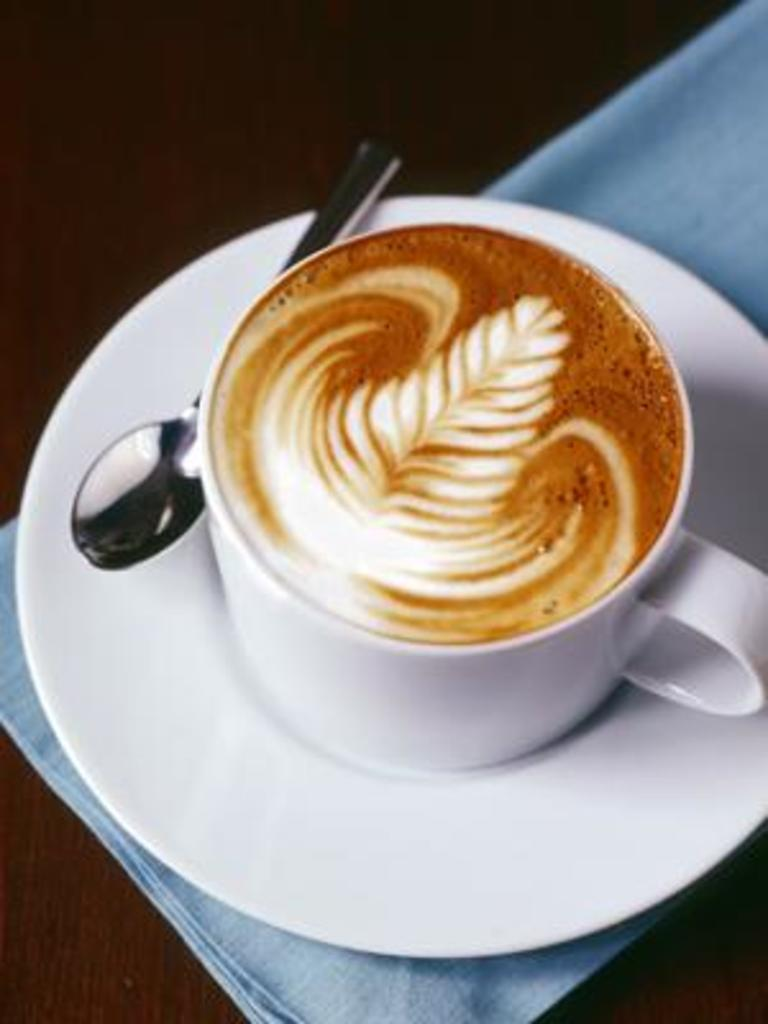What is present on the table in the image? There is a coffee cup, a saucer, and a spoon in the image. What might be used to stir the contents of the coffee cup? The spoon in the image can be used to stir the contents of the coffee cup. What is placed beneath the coffee cup in the image? There is a saucer beneath the coffee cup in the image. What is covering the table in the image? There is a cloth on the table in the image. What type of hat is the coffee cup wearing in the image? There is no hat present in the image, as the coffee cup is not a person or an animal. 